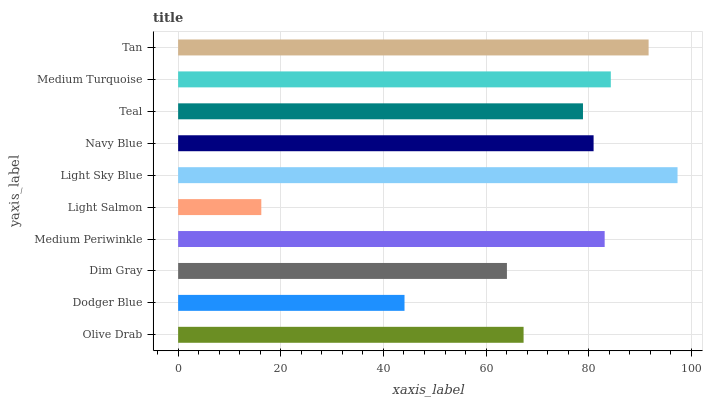Is Light Salmon the minimum?
Answer yes or no. Yes. Is Light Sky Blue the maximum?
Answer yes or no. Yes. Is Dodger Blue the minimum?
Answer yes or no. No. Is Dodger Blue the maximum?
Answer yes or no. No. Is Olive Drab greater than Dodger Blue?
Answer yes or no. Yes. Is Dodger Blue less than Olive Drab?
Answer yes or no. Yes. Is Dodger Blue greater than Olive Drab?
Answer yes or no. No. Is Olive Drab less than Dodger Blue?
Answer yes or no. No. Is Navy Blue the high median?
Answer yes or no. Yes. Is Teal the low median?
Answer yes or no. Yes. Is Medium Turquoise the high median?
Answer yes or no. No. Is Light Sky Blue the low median?
Answer yes or no. No. 